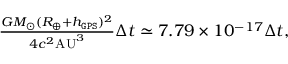Convert formula to latex. <formula><loc_0><loc_0><loc_500><loc_500>\begin{array} { r } { \frac { G M _ { \odot } ( R _ { \oplus } + h _ { \tt G P S } ) ^ { 2 } } { 4 c ^ { 2 } A U ^ { 3 } } \Delta t \simeq 7 . 7 9 \times 1 0 ^ { - 1 7 } \Delta t , } \end{array}</formula> 